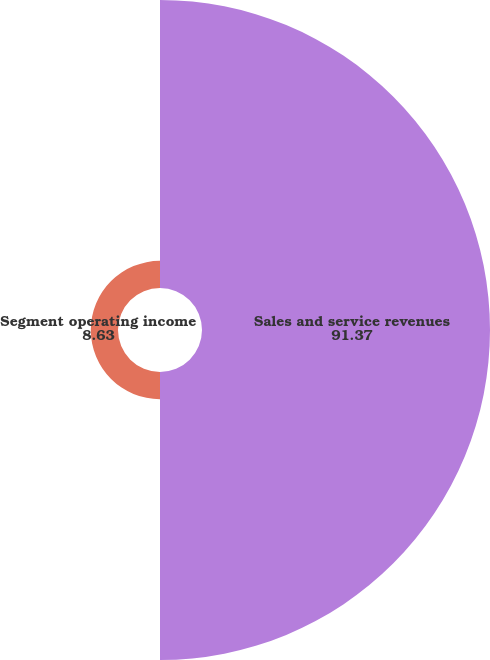Convert chart to OTSL. <chart><loc_0><loc_0><loc_500><loc_500><pie_chart><fcel>Sales and service revenues<fcel>Segment operating income<nl><fcel>91.37%<fcel>8.63%<nl></chart> 